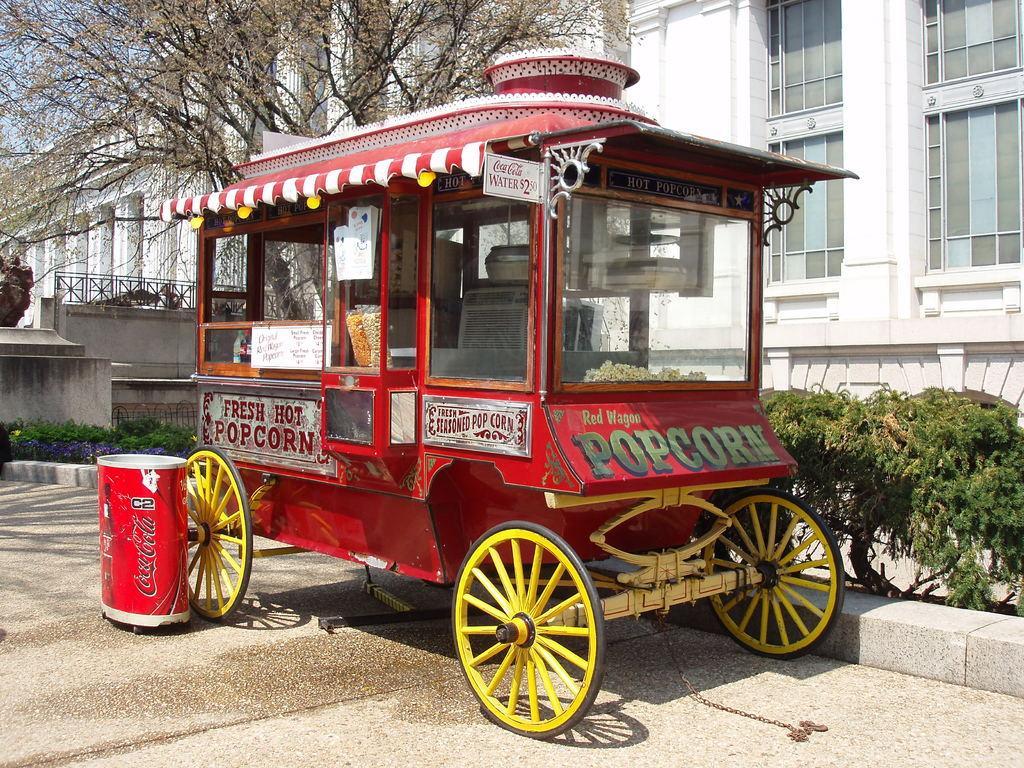Describe this image in one or two sentences. In the picture I can see a vehicle, a dustbin, plants, a building which is white in color and a tree. In the background I can see the sky. 